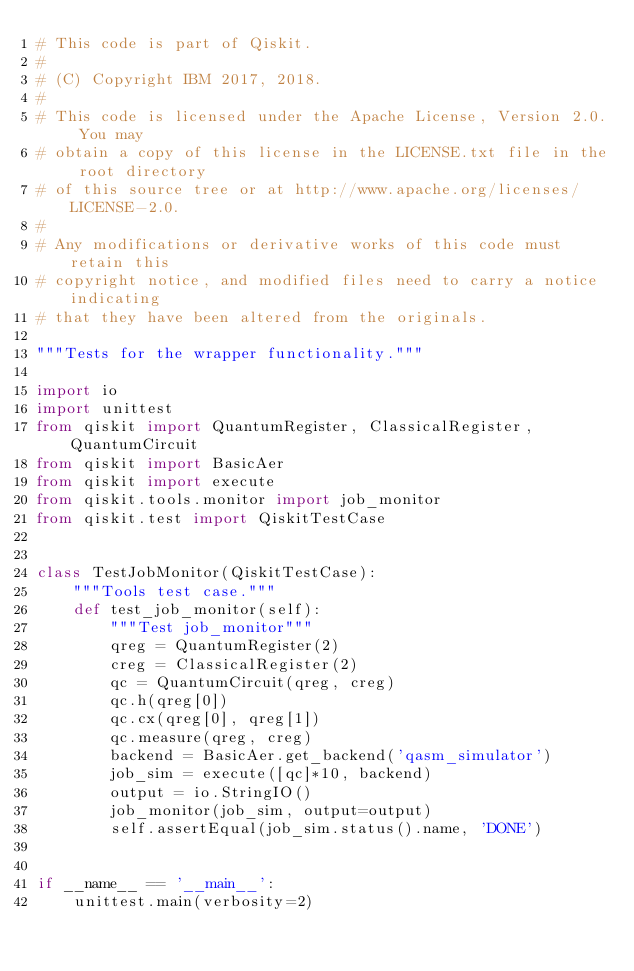<code> <loc_0><loc_0><loc_500><loc_500><_Python_># This code is part of Qiskit.
#
# (C) Copyright IBM 2017, 2018.
#
# This code is licensed under the Apache License, Version 2.0. You may
# obtain a copy of this license in the LICENSE.txt file in the root directory
# of this source tree or at http://www.apache.org/licenses/LICENSE-2.0.
#
# Any modifications or derivative works of this code must retain this
# copyright notice, and modified files need to carry a notice indicating
# that they have been altered from the originals.

"""Tests for the wrapper functionality."""

import io
import unittest
from qiskit import QuantumRegister, ClassicalRegister, QuantumCircuit
from qiskit import BasicAer
from qiskit import execute
from qiskit.tools.monitor import job_monitor
from qiskit.test import QiskitTestCase


class TestJobMonitor(QiskitTestCase):
    """Tools test case."""
    def test_job_monitor(self):
        """Test job_monitor"""
        qreg = QuantumRegister(2)
        creg = ClassicalRegister(2)
        qc = QuantumCircuit(qreg, creg)
        qc.h(qreg[0])
        qc.cx(qreg[0], qreg[1])
        qc.measure(qreg, creg)
        backend = BasicAer.get_backend('qasm_simulator')
        job_sim = execute([qc]*10, backend)
        output = io.StringIO()
        job_monitor(job_sim, output=output)
        self.assertEqual(job_sim.status().name, 'DONE')


if __name__ == '__main__':
    unittest.main(verbosity=2)
</code> 